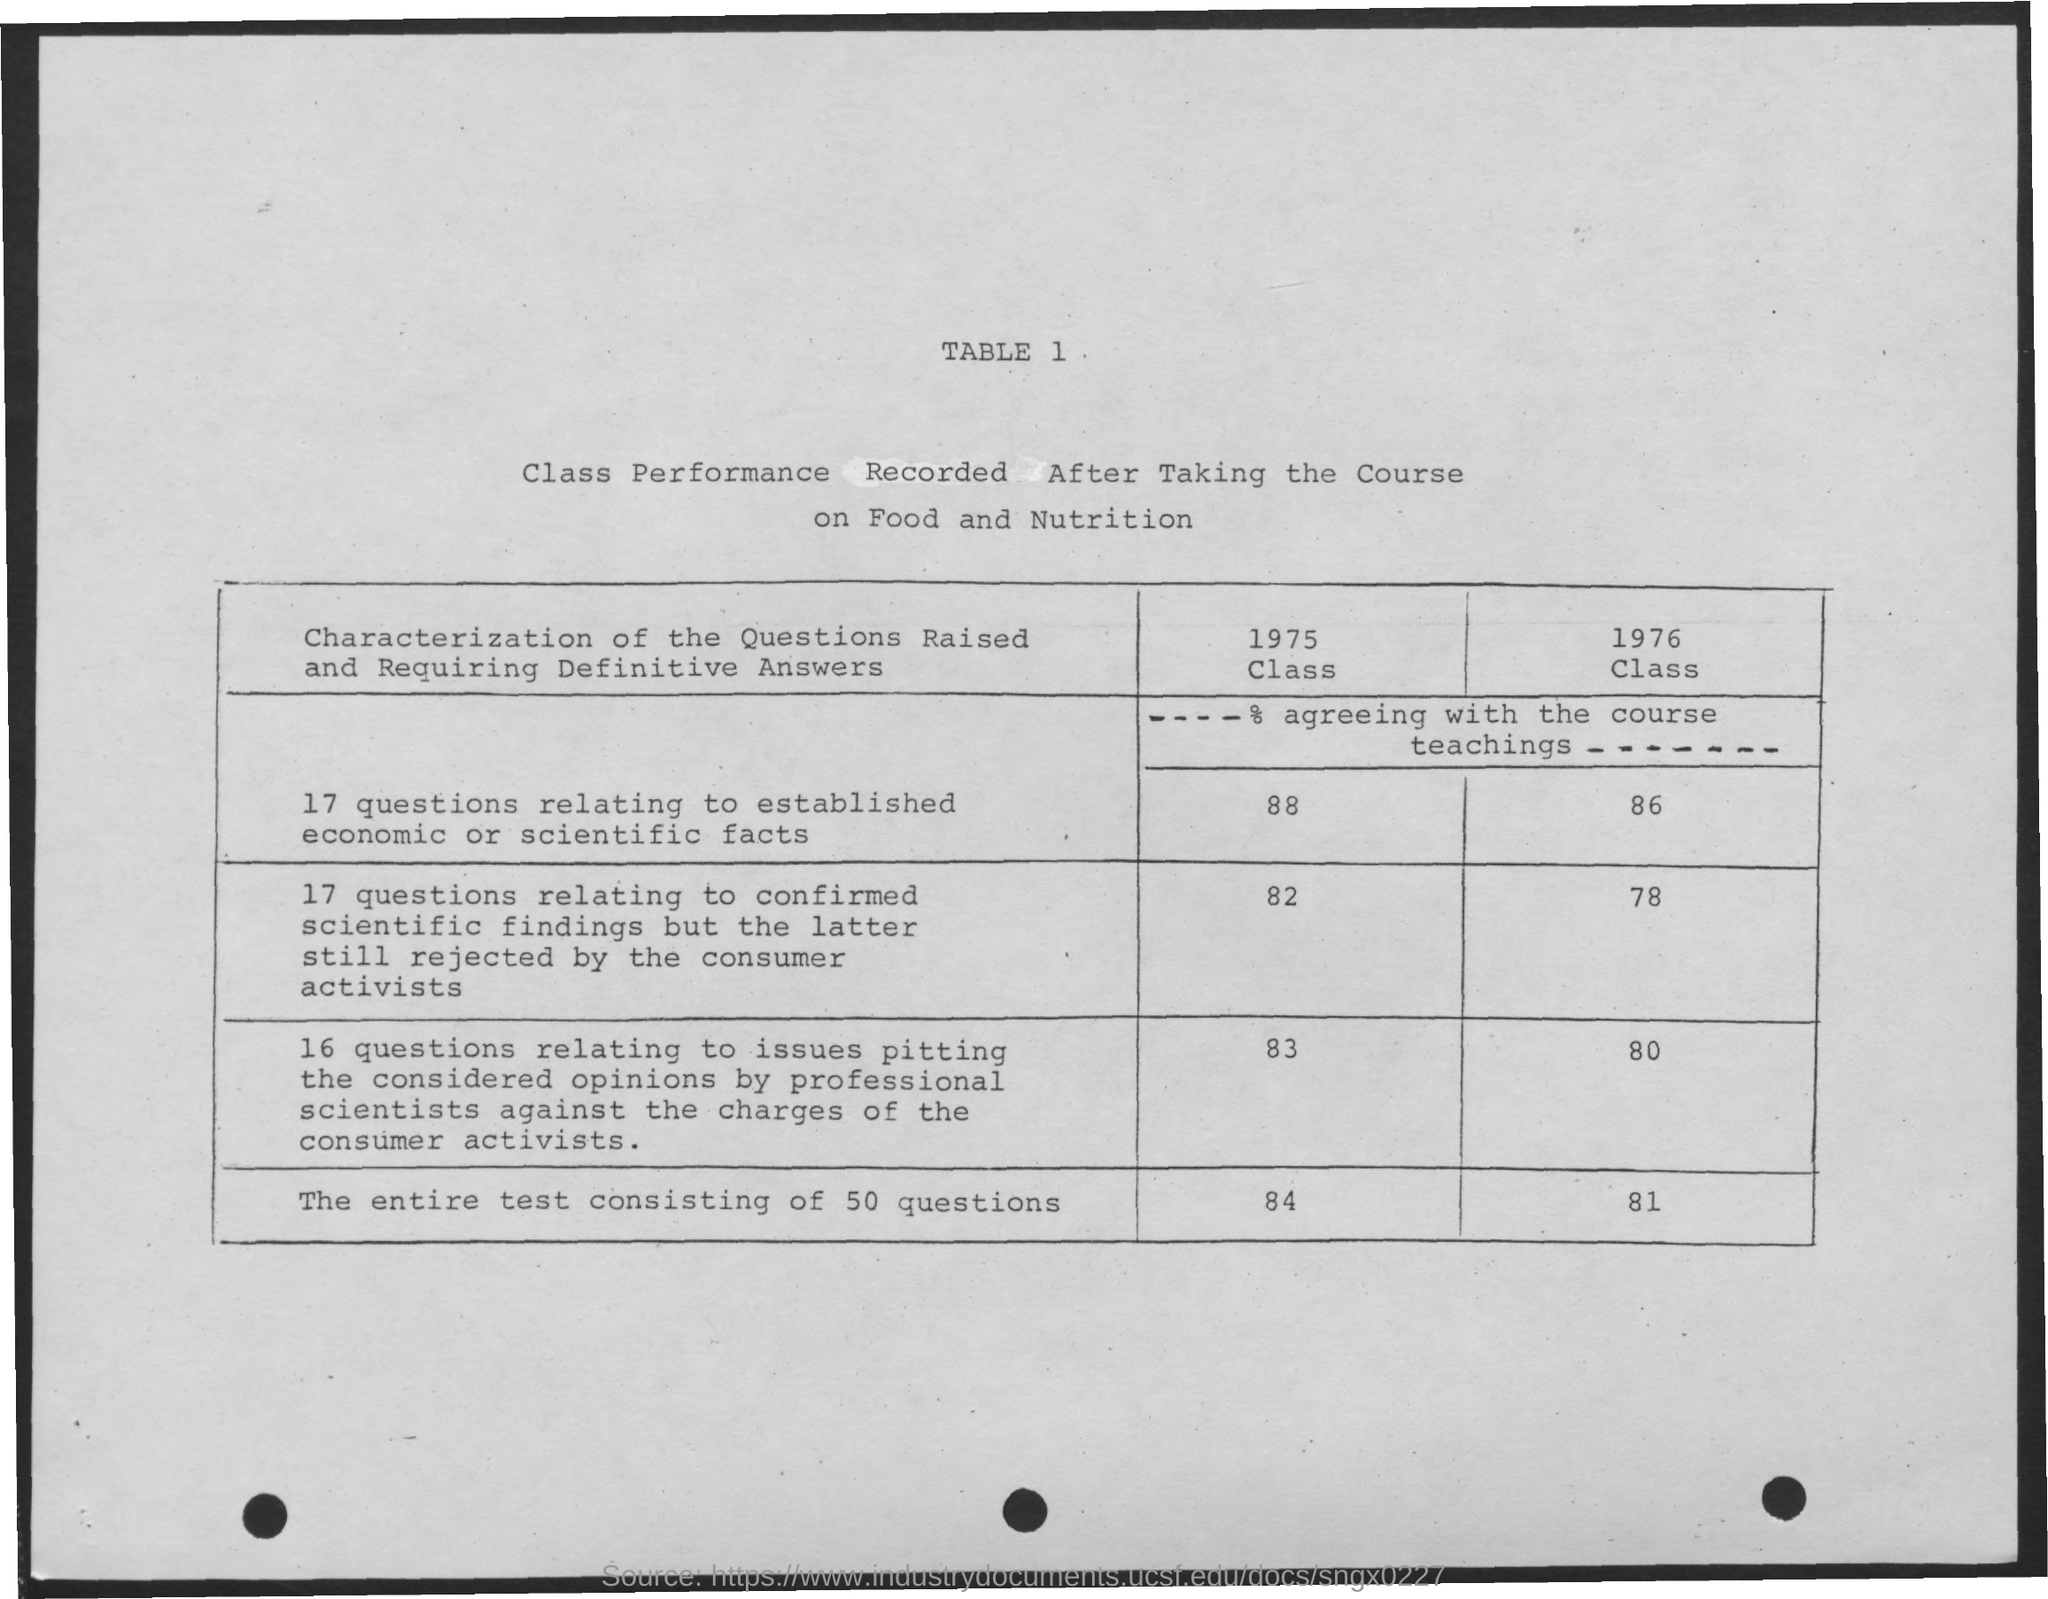Give some essential details in this illustration. This table is about a class performance record for students who have taken a course on food and nutrition. The record includes information about their performance in the course. The heading of the document is TABLE 1, which provides information relevant to the topic at hand. 